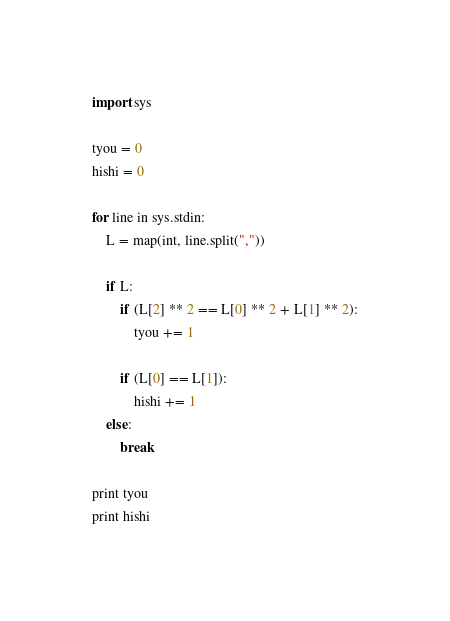<code> <loc_0><loc_0><loc_500><loc_500><_Python_>import sys

tyou = 0
hishi = 0

for line in sys.stdin:
    L = map(int, line.split(","))
    
    if L:
        if (L[2] ** 2 == L[0] ** 2 + L[1] ** 2):
            tyou += 1

        if (L[0] == L[1]):
            hishi += 1
    else:
        break

print tyou
print hishi</code> 